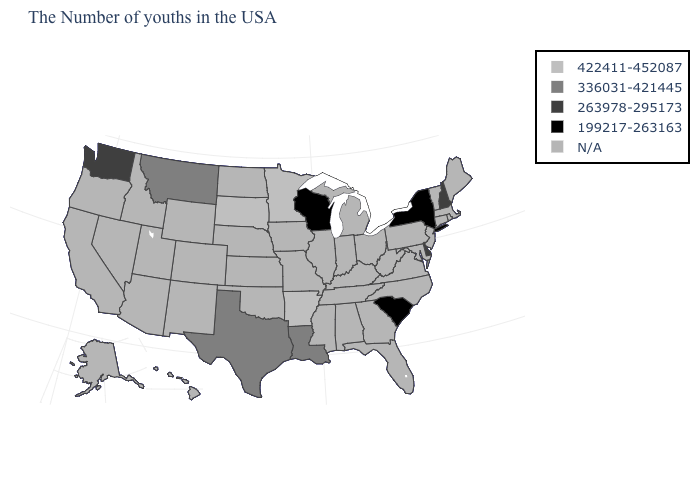Which states hav the highest value in the MidWest?
Quick response, please. Minnesota, South Dakota. What is the value of Pennsylvania?
Keep it brief. N/A. Which states have the lowest value in the USA?
Keep it brief. New York, South Carolina, Wisconsin. How many symbols are there in the legend?
Give a very brief answer. 5. Name the states that have a value in the range 263978-295173?
Be succinct. New Hampshire, Delaware, Washington. What is the value of Arizona?
Be succinct. N/A. Does New Hampshire have the lowest value in the USA?
Answer briefly. No. Which states have the highest value in the USA?
Write a very short answer. Arkansas, Minnesota, South Dakota. What is the value of South Dakota?
Short answer required. 422411-452087. Does Louisiana have the lowest value in the South?
Be succinct. No. What is the lowest value in states that border Mississippi?
Short answer required. 336031-421445. Does the map have missing data?
Give a very brief answer. Yes. 